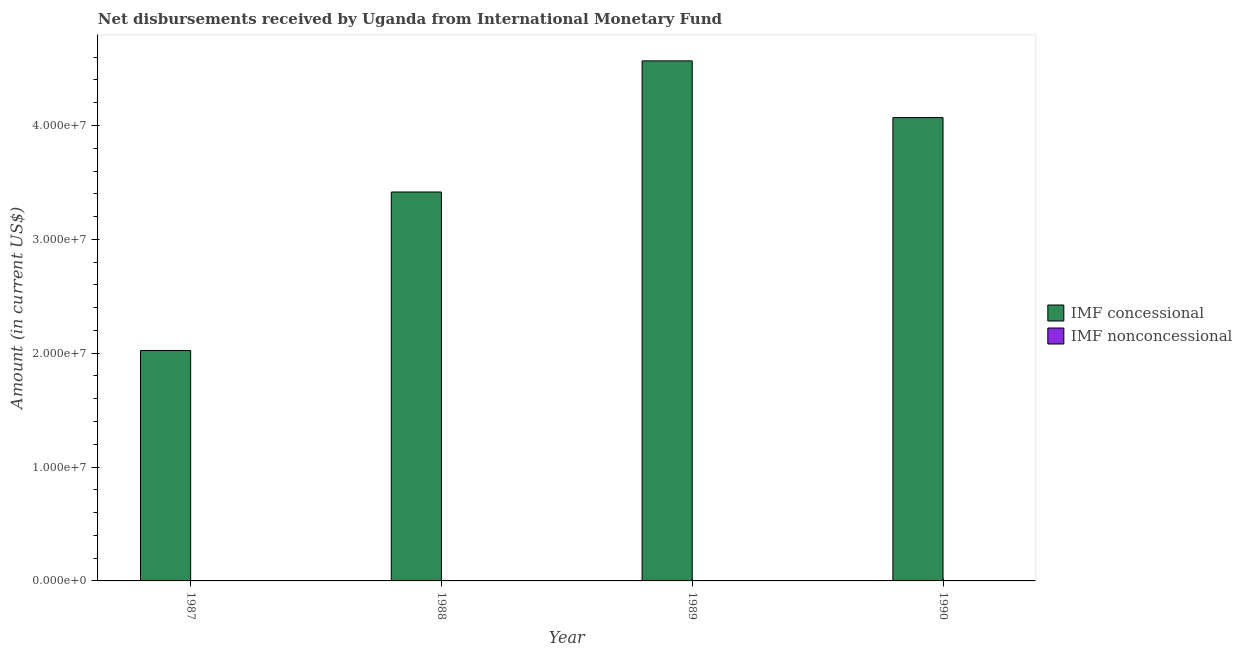How many different coloured bars are there?
Provide a succinct answer. 1. How many bars are there on the 3rd tick from the left?
Your answer should be very brief. 1. How many bars are there on the 1st tick from the right?
Make the answer very short. 1. In how many cases, is the number of bars for a given year not equal to the number of legend labels?
Your response must be concise. 4. What is the net concessional disbursements from imf in 1988?
Provide a short and direct response. 3.42e+07. Across all years, what is the maximum net concessional disbursements from imf?
Provide a succinct answer. 4.57e+07. Across all years, what is the minimum net concessional disbursements from imf?
Provide a succinct answer. 2.02e+07. In which year was the net concessional disbursements from imf maximum?
Your answer should be compact. 1989. What is the total net concessional disbursements from imf in the graph?
Keep it short and to the point. 1.41e+08. What is the difference between the net concessional disbursements from imf in 1987 and that in 1988?
Provide a short and direct response. -1.39e+07. What is the difference between the net non concessional disbursements from imf in 1988 and the net concessional disbursements from imf in 1989?
Ensure brevity in your answer.  0. What is the average net concessional disbursements from imf per year?
Provide a succinct answer. 3.52e+07. In the year 1990, what is the difference between the net concessional disbursements from imf and net non concessional disbursements from imf?
Offer a terse response. 0. What is the ratio of the net concessional disbursements from imf in 1989 to that in 1990?
Keep it short and to the point. 1.12. What is the difference between the highest and the second highest net concessional disbursements from imf?
Offer a terse response. 4.98e+06. What is the difference between the highest and the lowest net concessional disbursements from imf?
Ensure brevity in your answer.  2.54e+07. In how many years, is the net concessional disbursements from imf greater than the average net concessional disbursements from imf taken over all years?
Offer a terse response. 2. How many bars are there?
Your response must be concise. 4. Does the graph contain any zero values?
Ensure brevity in your answer.  Yes. Does the graph contain grids?
Your response must be concise. No. Where does the legend appear in the graph?
Offer a very short reply. Center right. How many legend labels are there?
Your answer should be very brief. 2. How are the legend labels stacked?
Provide a short and direct response. Vertical. What is the title of the graph?
Provide a succinct answer. Net disbursements received by Uganda from International Monetary Fund. Does "Primary completion rate" appear as one of the legend labels in the graph?
Keep it short and to the point. No. What is the label or title of the Y-axis?
Your response must be concise. Amount (in current US$). What is the Amount (in current US$) in IMF concessional in 1987?
Your answer should be compact. 2.02e+07. What is the Amount (in current US$) in IMF concessional in 1988?
Make the answer very short. 3.42e+07. What is the Amount (in current US$) in IMF concessional in 1989?
Ensure brevity in your answer.  4.57e+07. What is the Amount (in current US$) in IMF nonconcessional in 1989?
Your answer should be compact. 0. What is the Amount (in current US$) in IMF concessional in 1990?
Offer a terse response. 4.07e+07. What is the Amount (in current US$) of IMF nonconcessional in 1990?
Provide a succinct answer. 0. Across all years, what is the maximum Amount (in current US$) in IMF concessional?
Make the answer very short. 4.57e+07. Across all years, what is the minimum Amount (in current US$) in IMF concessional?
Offer a very short reply. 2.02e+07. What is the total Amount (in current US$) of IMF concessional in the graph?
Make the answer very short. 1.41e+08. What is the total Amount (in current US$) of IMF nonconcessional in the graph?
Give a very brief answer. 0. What is the difference between the Amount (in current US$) of IMF concessional in 1987 and that in 1988?
Your answer should be compact. -1.39e+07. What is the difference between the Amount (in current US$) in IMF concessional in 1987 and that in 1989?
Provide a succinct answer. -2.54e+07. What is the difference between the Amount (in current US$) in IMF concessional in 1987 and that in 1990?
Make the answer very short. -2.05e+07. What is the difference between the Amount (in current US$) of IMF concessional in 1988 and that in 1989?
Give a very brief answer. -1.15e+07. What is the difference between the Amount (in current US$) in IMF concessional in 1988 and that in 1990?
Give a very brief answer. -6.54e+06. What is the difference between the Amount (in current US$) in IMF concessional in 1989 and that in 1990?
Provide a short and direct response. 4.98e+06. What is the average Amount (in current US$) in IMF concessional per year?
Your answer should be very brief. 3.52e+07. What is the ratio of the Amount (in current US$) of IMF concessional in 1987 to that in 1988?
Offer a terse response. 0.59. What is the ratio of the Amount (in current US$) of IMF concessional in 1987 to that in 1989?
Keep it short and to the point. 0.44. What is the ratio of the Amount (in current US$) in IMF concessional in 1987 to that in 1990?
Give a very brief answer. 0.5. What is the ratio of the Amount (in current US$) of IMF concessional in 1988 to that in 1989?
Give a very brief answer. 0.75. What is the ratio of the Amount (in current US$) in IMF concessional in 1988 to that in 1990?
Give a very brief answer. 0.84. What is the ratio of the Amount (in current US$) in IMF concessional in 1989 to that in 1990?
Keep it short and to the point. 1.12. What is the difference between the highest and the second highest Amount (in current US$) of IMF concessional?
Keep it short and to the point. 4.98e+06. What is the difference between the highest and the lowest Amount (in current US$) in IMF concessional?
Your answer should be very brief. 2.54e+07. 